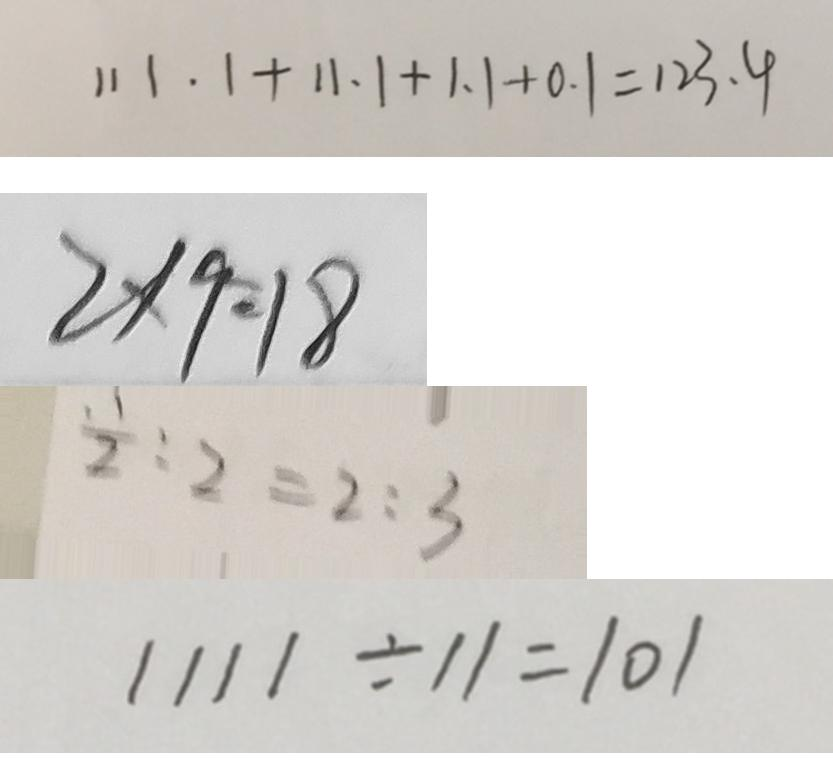Convert formula to latex. <formula><loc_0><loc_0><loc_500><loc_500>1 1 1 . 1 + 1 1 . 1 + 1 . 1 + 0 . 1 = 1 2 3 . 4 
 2 \times 9 = 1 8 
 \frac { 1 } { 2 } : 2 = 2 : 3 
 1 1 1 1 \div 1 1 = 1 0 1</formula> 